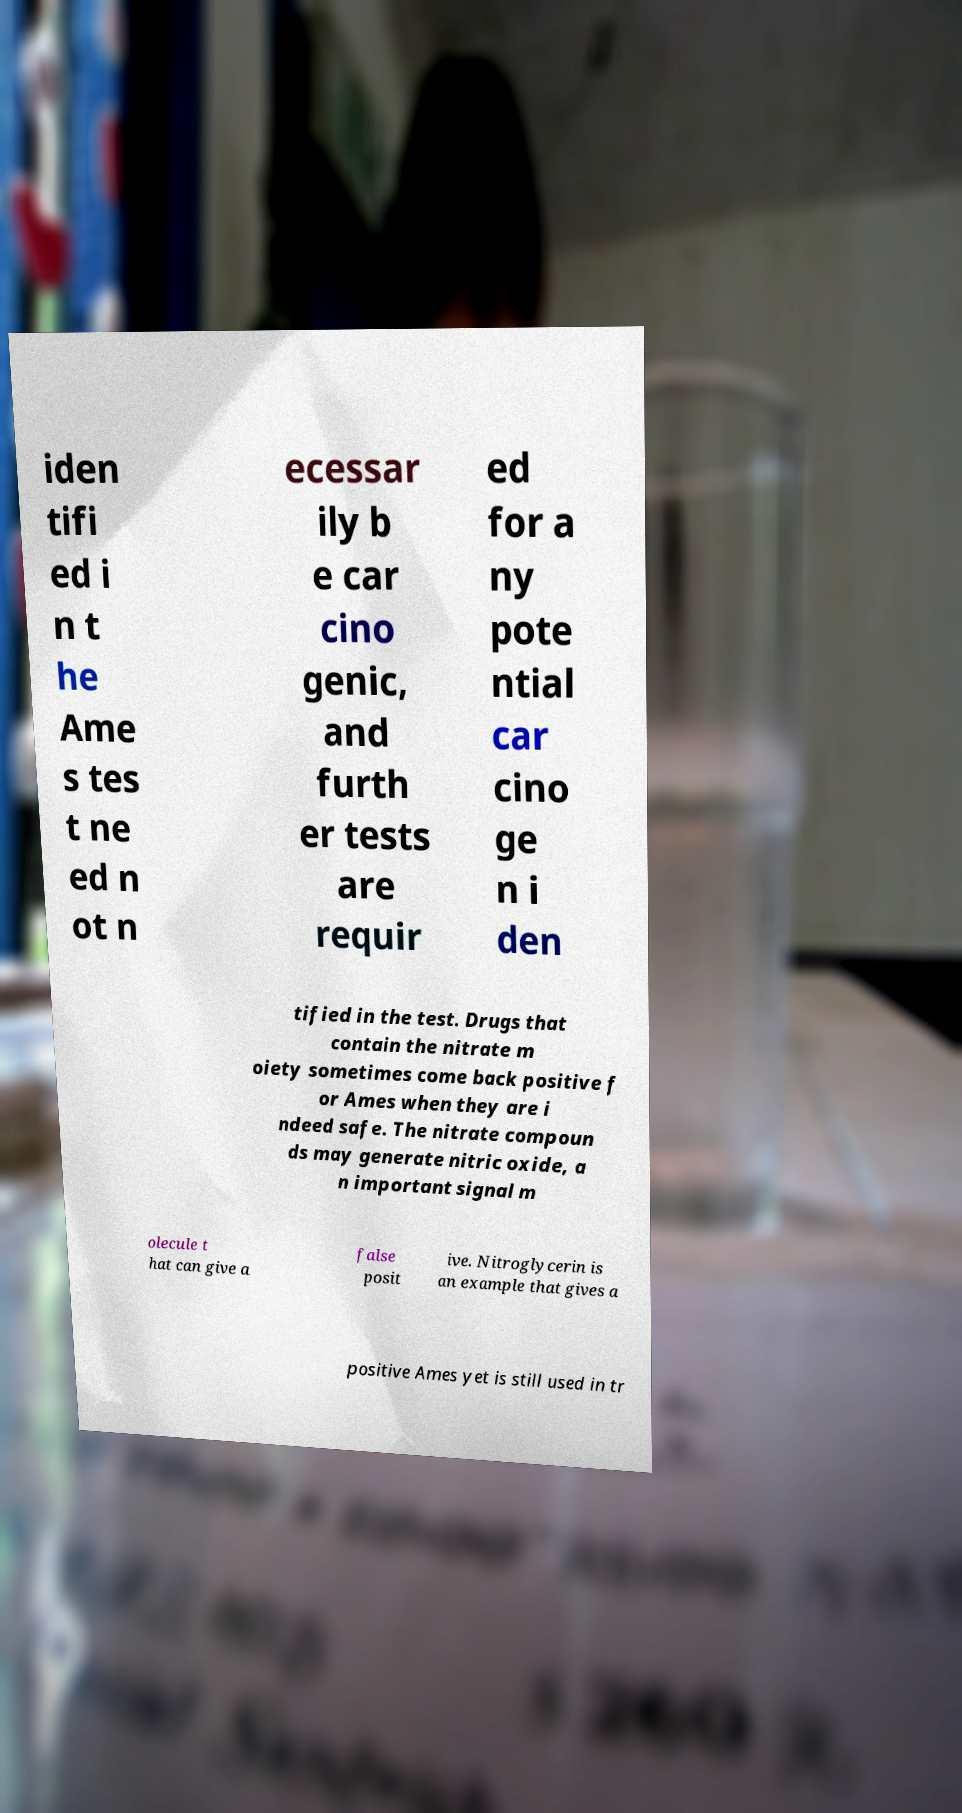Could you extract and type out the text from this image? iden tifi ed i n t he Ame s tes t ne ed n ot n ecessar ily b e car cino genic, and furth er tests are requir ed for a ny pote ntial car cino ge n i den tified in the test. Drugs that contain the nitrate m oiety sometimes come back positive f or Ames when they are i ndeed safe. The nitrate compoun ds may generate nitric oxide, a n important signal m olecule t hat can give a false posit ive. Nitroglycerin is an example that gives a positive Ames yet is still used in tr 